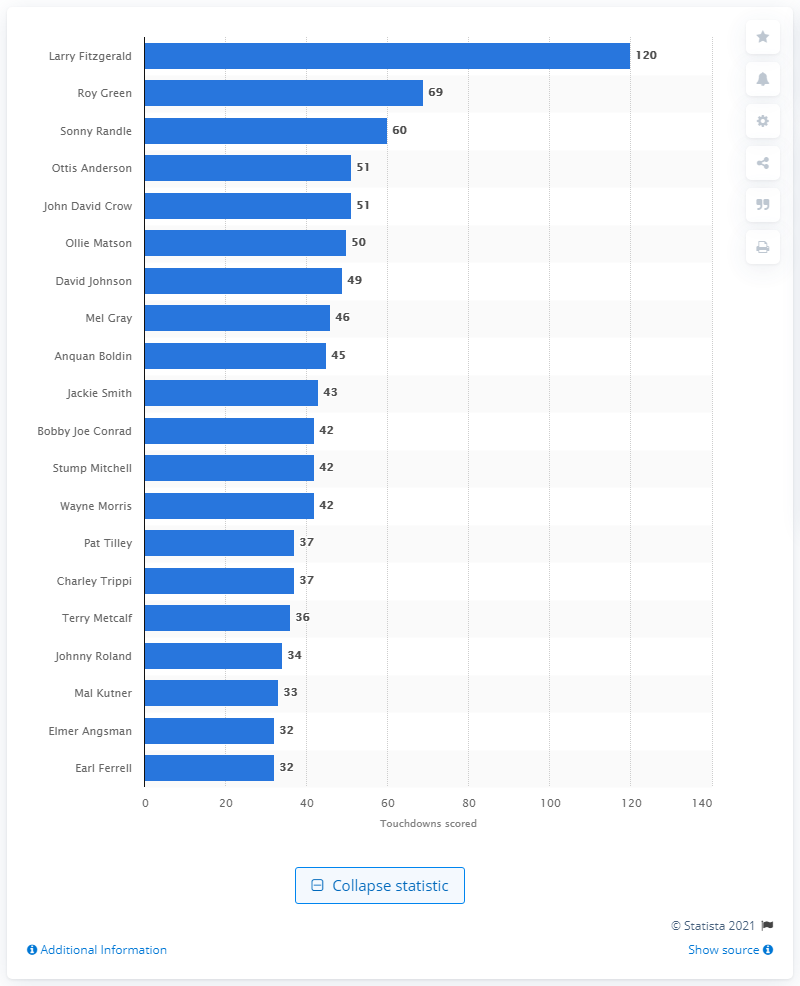Mention a couple of crucial points in this snapshot. Larry Fitzgerald, a star wide receiver for the Arizona Cardinals, has scored a total of 120 career touchdowns. I, Larry Fitzgerald, am the career touchdown leader of the Arizona Cardinals. 